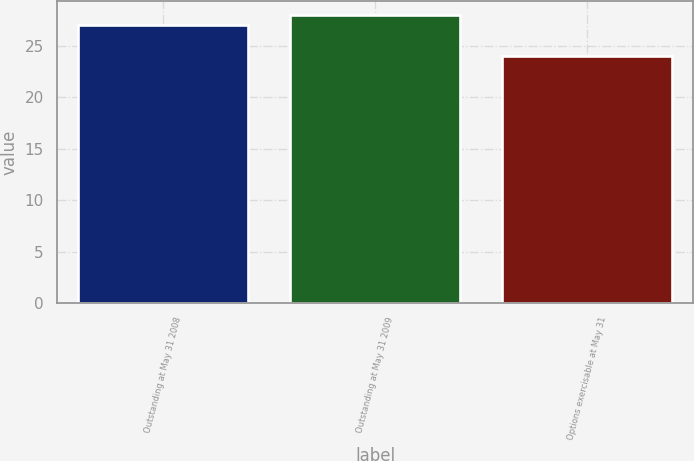<chart> <loc_0><loc_0><loc_500><loc_500><bar_chart><fcel>Outstanding at May 31 2008<fcel>Outstanding at May 31 2009<fcel>Options exercisable at May 31<nl><fcel>27<fcel>28<fcel>24<nl></chart> 